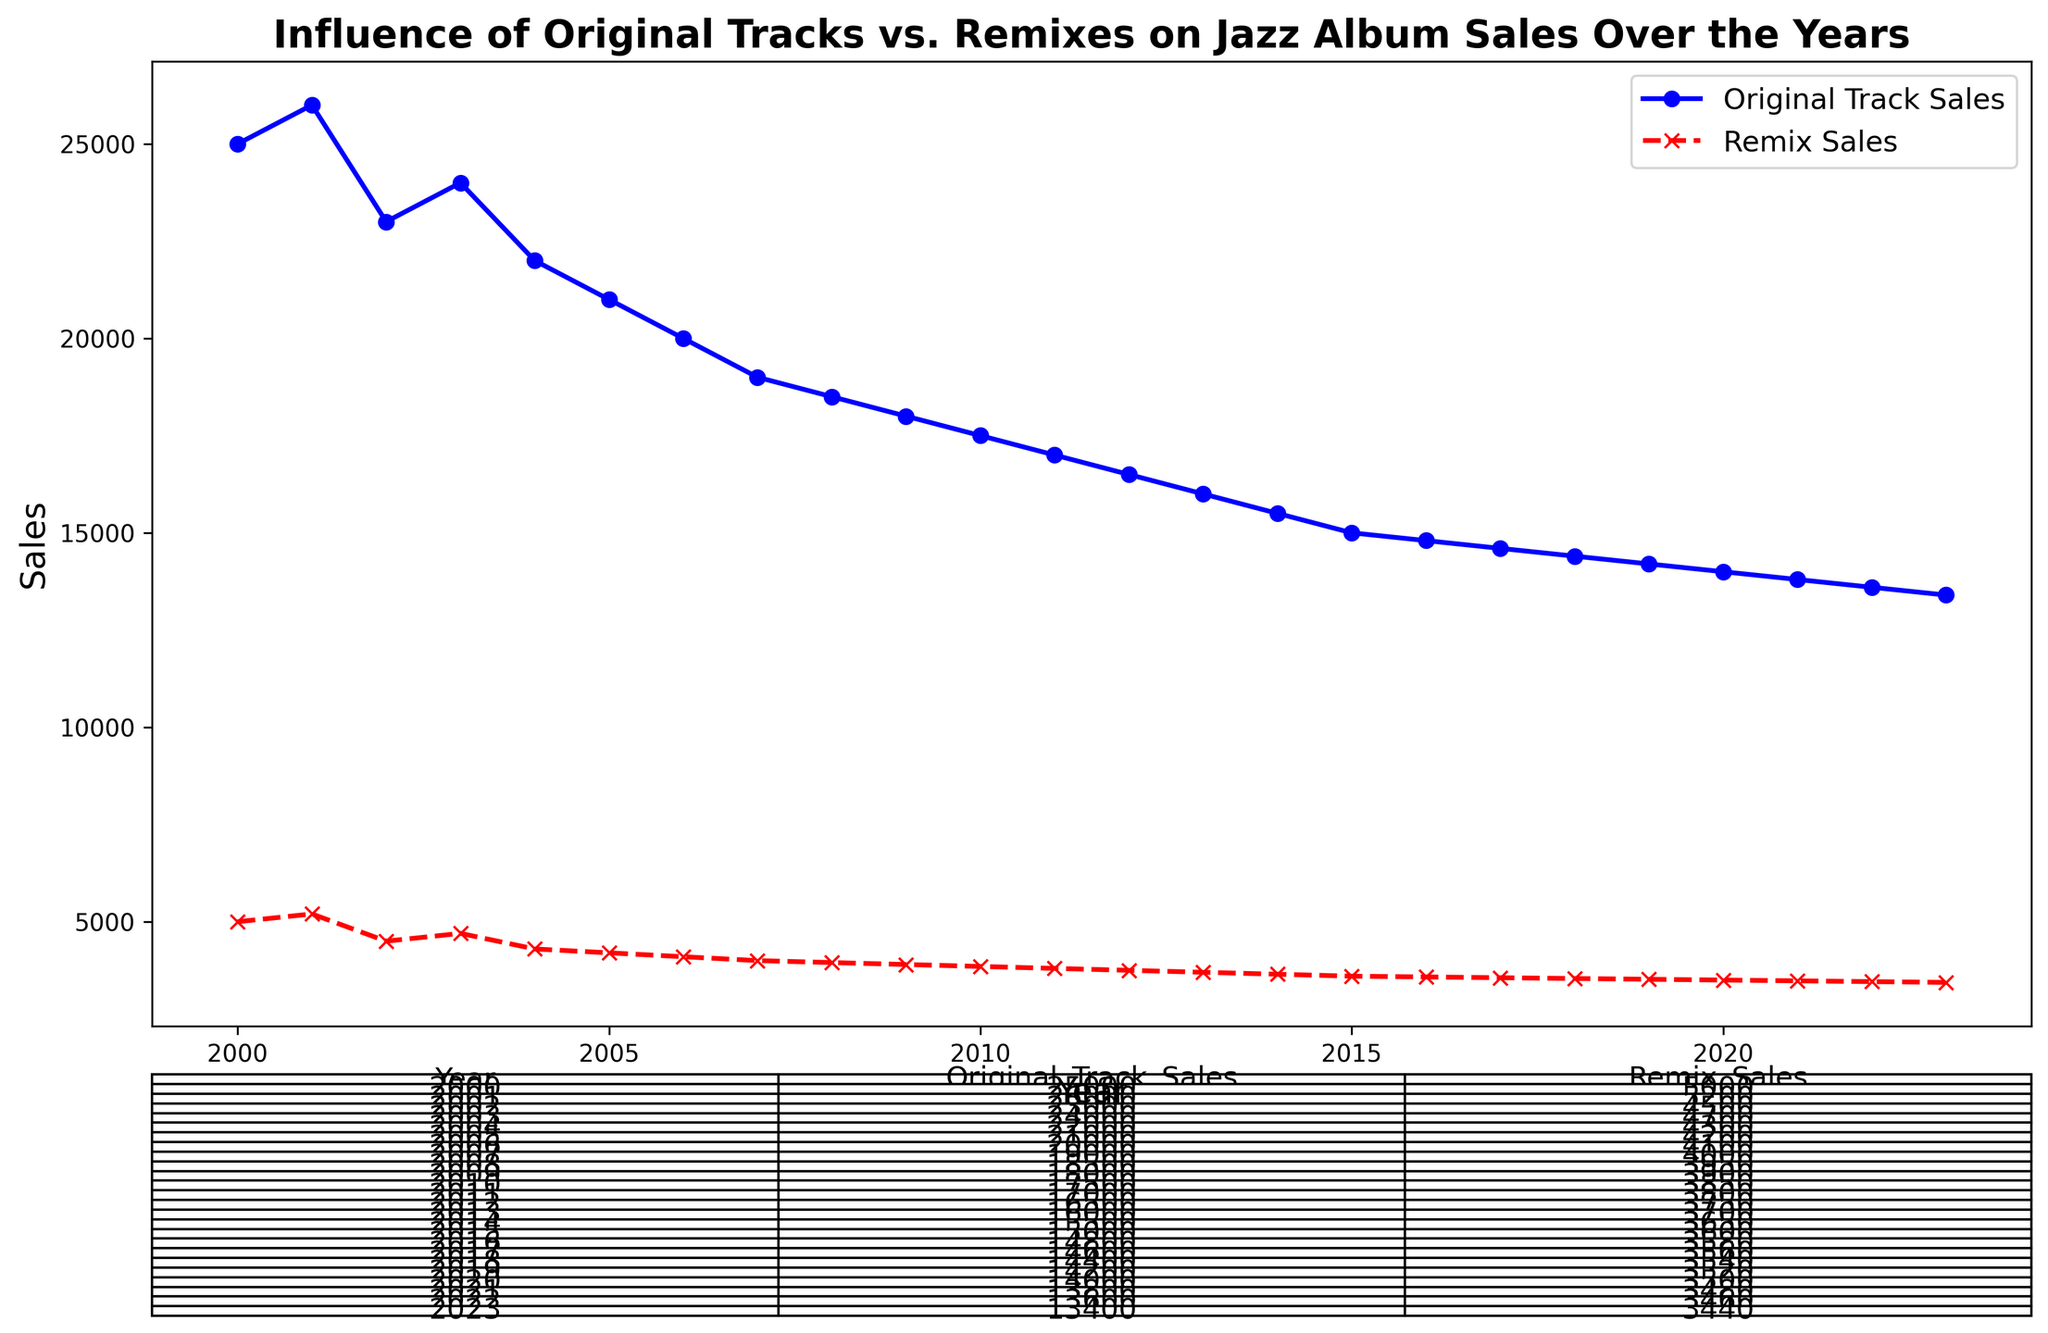What was the overall trend in Original Track Sales from 2000 to 2023? The graph for Original Track Sales shows a steady decline from 2000 (25,000 sales) to 2023 (13,400 sales). To determine this, observe the blue line in the chart, which slopes downward as the years progress.
Answer: Declining How does the sales trend for Remix Sales compare to that of Original Track Sales over the same period? Both sales trends show a decline over the years. However, Remix Sales, represented by the red dashed line, decline at a slightly slower rate compared to the Original Track Sales, shown by the solid blue line. Comparing the slopes visually, Remix Sales have a gentler slope.
Answer: Remix Sales decline slower What was the difference in sales between Original Tracks and Remixes in the year 2005? In 2005, Original Track Sales were 21,000, while Remix Sales were 4,200. The difference can be calculated as 21,000 - 4,200.
Answer: 16,800 What year had the smallest difference between Original Track Sales and Remix Sales, and what was that difference? To find the smallest difference, observe the year where the two lines are closest. In 2023, Original Track Sales were 13,400 and Remix Sales were 3,440, making the difference 13,400 - 3,440.
Answer: 2023, 9,960 Which year recorded the highest Remix Sales and what was the value? The highest Remix Sales occurred in 2001, where the sales reached 5,200. This is deduced by looking for the peak value on the red dashed line.
Answer: 2001, 5,200 What is the average Remix Sales from 2000 to 2023? To find the average, sum the Remix Sales for each year, then divide by the number of years (24). The total sum = 88,050. Average = 88,050 / 24.
Answer: 3,669 By how much did Original Track Sales decrease from 2000 to 2023? The Original Track Sales in 2000 were 25,000 and 13,400 in 2023. The decrease is calculated as 25,000 - 13,400.
Answer: 11,600 What was the percentage decrease in Original Track Sales from 2000 to 2023? First, find the decrease amount, which is 11,600. Then, divide this by the original amount in 2000, which is 25,000, and multiply by 100 to get the percentage.
Answer: 46.4% What is the sum of Original Track Sales and Remix Sales in the year 2012? In 2012, Original Track Sales were 16,500 and Remix Sales were 3,750. The sum is 16,500 + 3,750.
Answer: 20,250 During which year did both Original Track Sales and Remix Sales combined peak the highest, and what was the value? This requires calculating the combined sales for each year and identifying the highest sum. The highest combined value occurs in 2001 with Original Track Sales of 26,000 and Remix Sales of 5,200. The combined value is 26,000 + 5,200.
Answer: 2001, 31,200 